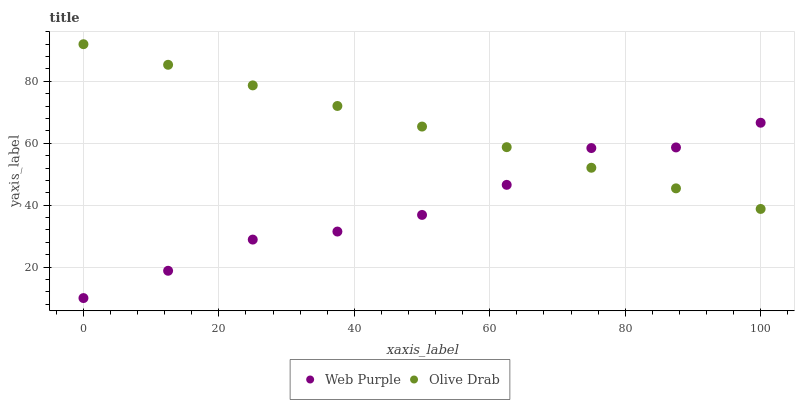Does Web Purple have the minimum area under the curve?
Answer yes or no. Yes. Does Olive Drab have the maximum area under the curve?
Answer yes or no. Yes. Does Olive Drab have the minimum area under the curve?
Answer yes or no. No. Is Olive Drab the smoothest?
Answer yes or no. Yes. Is Web Purple the roughest?
Answer yes or no. Yes. Is Olive Drab the roughest?
Answer yes or no. No. Does Web Purple have the lowest value?
Answer yes or no. Yes. Does Olive Drab have the lowest value?
Answer yes or no. No. Does Olive Drab have the highest value?
Answer yes or no. Yes. Does Olive Drab intersect Web Purple?
Answer yes or no. Yes. Is Olive Drab less than Web Purple?
Answer yes or no. No. Is Olive Drab greater than Web Purple?
Answer yes or no. No. 